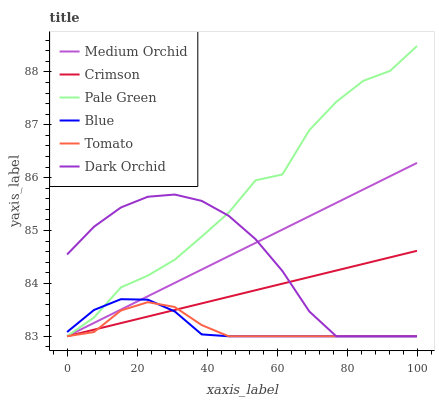Does Tomato have the minimum area under the curve?
Answer yes or no. Yes. Does Pale Green have the maximum area under the curve?
Answer yes or no. Yes. Does Blue have the minimum area under the curve?
Answer yes or no. No. Does Blue have the maximum area under the curve?
Answer yes or no. No. Is Crimson the smoothest?
Answer yes or no. Yes. Is Pale Green the roughest?
Answer yes or no. Yes. Is Blue the smoothest?
Answer yes or no. No. Is Blue the roughest?
Answer yes or no. No. Does Tomato have the lowest value?
Answer yes or no. Yes. Does Pale Green have the highest value?
Answer yes or no. Yes. Does Blue have the highest value?
Answer yes or no. No. Does Medium Orchid intersect Blue?
Answer yes or no. Yes. Is Medium Orchid less than Blue?
Answer yes or no. No. Is Medium Orchid greater than Blue?
Answer yes or no. No. 